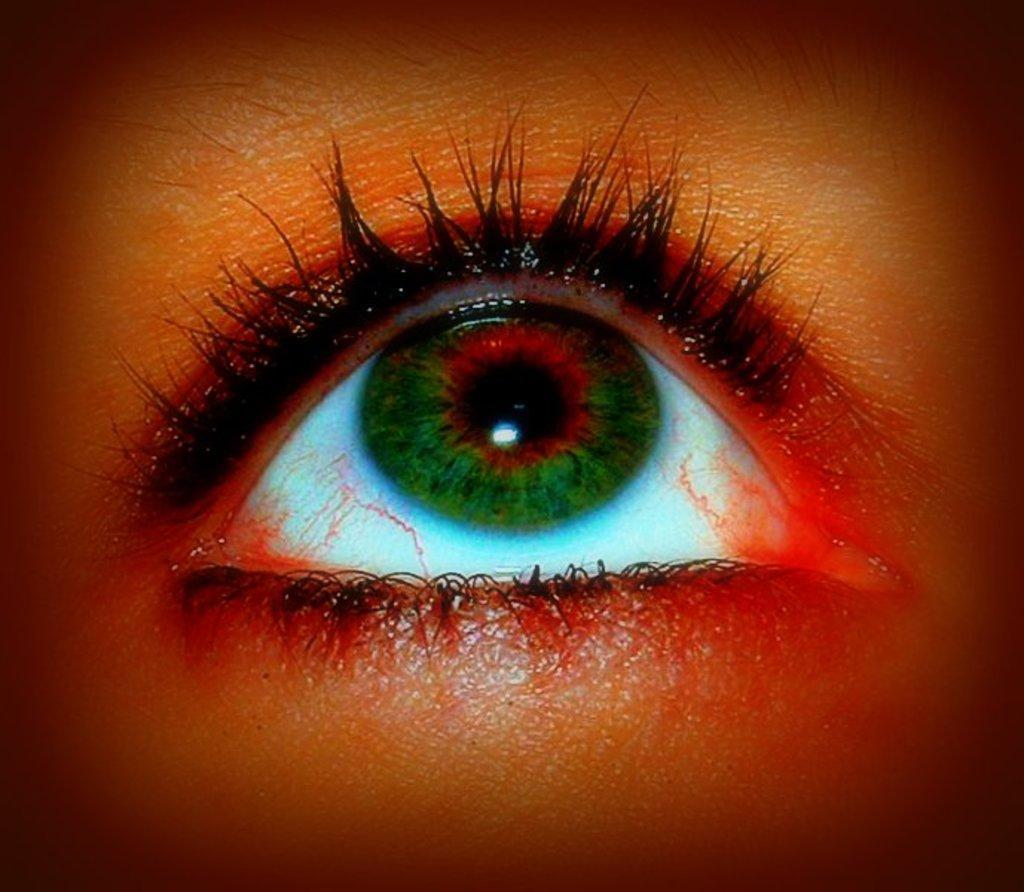How would you summarize this image in a sentence or two? This image consists of an eye in red color. In the middle, the eye is in green color. 